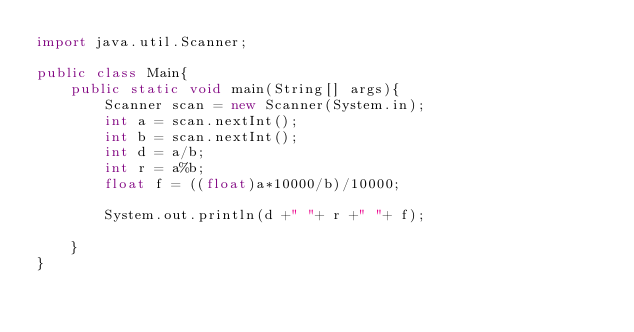<code> <loc_0><loc_0><loc_500><loc_500><_Java_>import java.util.Scanner;

public class Main{
	public static void main(String[] args){
		Scanner scan = new Scanner(System.in);
		int a = scan.nextInt();
		int b = scan.nextInt();
		int d = a/b;
		int r = a%b;
		float f = ((float)a*10000/b)/10000;

		System.out.println(d +" "+ r +" "+ f);

	}
}</code> 